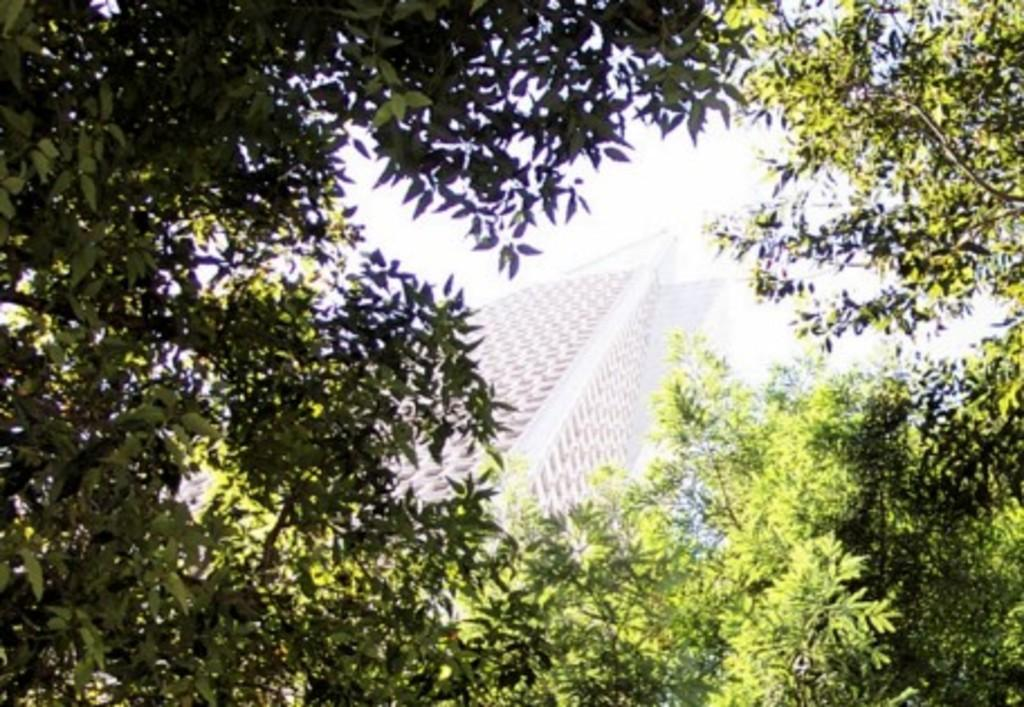What type of vegetation is visible in the front of the image? There are trees in the front of the image. What type of structure can be seen in the background of the image? There is a building in the background of the image. What part of the natural environment is visible in the image? The sky is visible in the background of the image. Can you see any fairies sitting on the sofa in the image? There are no fairies or sofas present in the image. Who is the manager of the building in the image? The image does not provide information about the management of the building. 